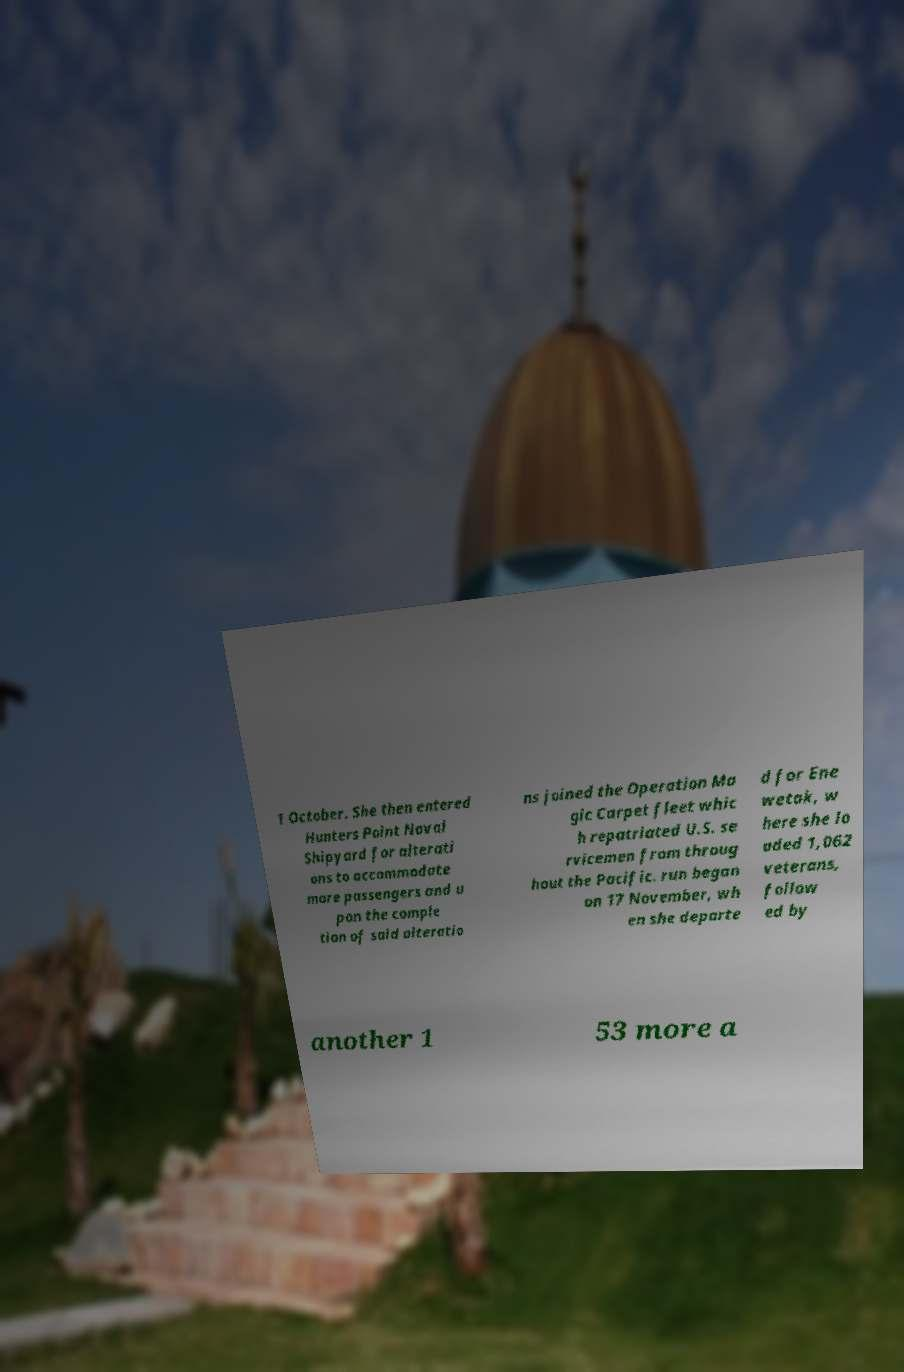There's text embedded in this image that I need extracted. Can you transcribe it verbatim? 1 October. She then entered Hunters Point Naval Shipyard for alterati ons to accommodate more passengers and u pon the comple tion of said alteratio ns joined the Operation Ma gic Carpet fleet whic h repatriated U.S. se rvicemen from throug hout the Pacific. run began on 17 November, wh en she departe d for Ene wetak, w here she lo aded 1,062 veterans, follow ed by another 1 53 more a 